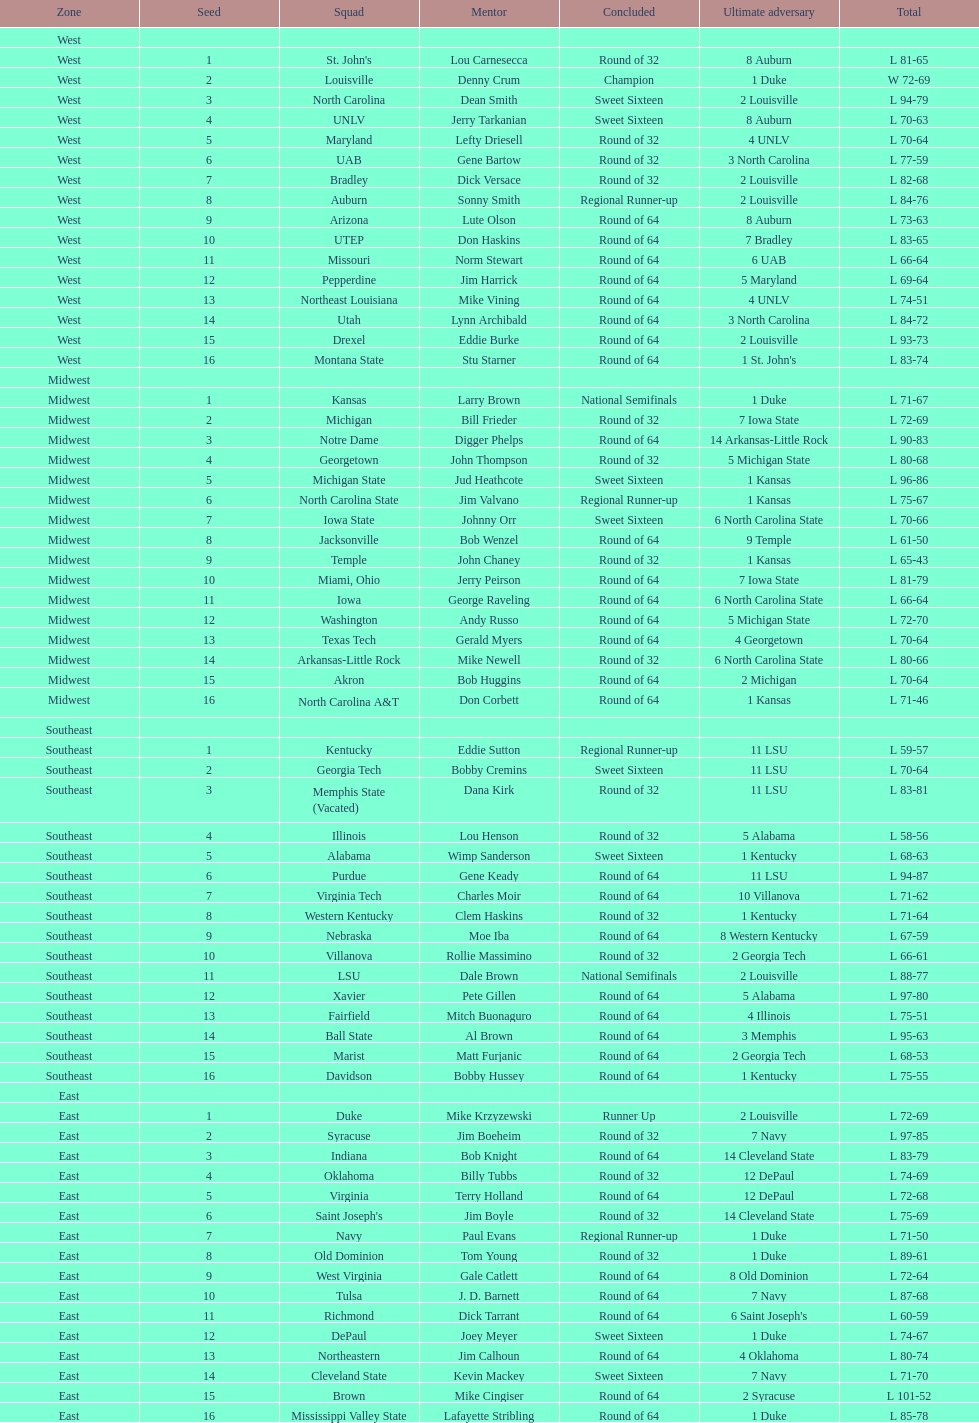How many 1 seeds are there? 4. 